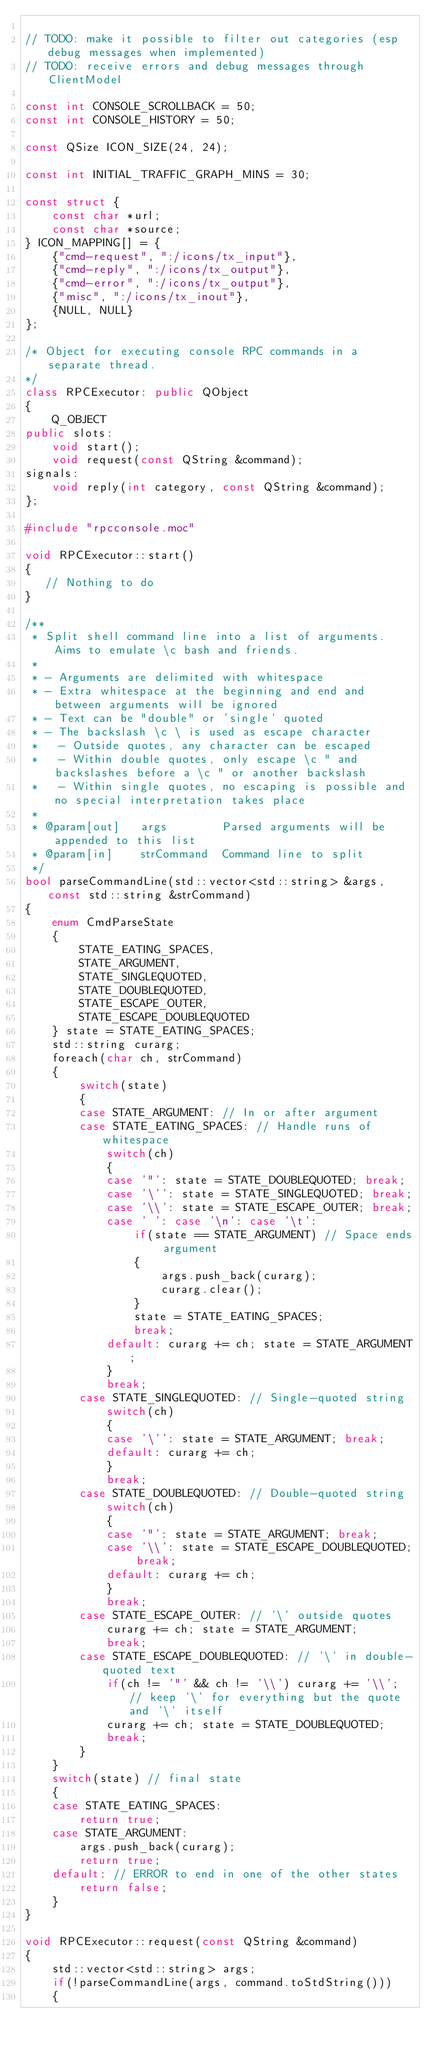Convert code to text. <code><loc_0><loc_0><loc_500><loc_500><_C++_>
// TODO: make it possible to filter out categories (esp debug messages when implemented)
// TODO: receive errors and debug messages through ClientModel

const int CONSOLE_SCROLLBACK = 50;
const int CONSOLE_HISTORY = 50;

const QSize ICON_SIZE(24, 24);

const int INITIAL_TRAFFIC_GRAPH_MINS = 30;

const struct {
    const char *url;
    const char *source;
} ICON_MAPPING[] = {
    {"cmd-request", ":/icons/tx_input"},
    {"cmd-reply", ":/icons/tx_output"},
    {"cmd-error", ":/icons/tx_output"},
    {"misc", ":/icons/tx_inout"},
    {NULL, NULL}
};

/* Object for executing console RPC commands in a separate thread.
*/
class RPCExecutor: public QObject
{
    Q_OBJECT
public slots:
    void start();
    void request(const QString &command);
signals:
    void reply(int category, const QString &command);
};

#include "rpcconsole.moc"

void RPCExecutor::start()
{
   // Nothing to do
}

/**
 * Split shell command line into a list of arguments. Aims to emulate \c bash and friends.
 *
 * - Arguments are delimited with whitespace
 * - Extra whitespace at the beginning and end and between arguments will be ignored
 * - Text can be "double" or 'single' quoted
 * - The backslash \c \ is used as escape character
 *   - Outside quotes, any character can be escaped
 *   - Within double quotes, only escape \c " and backslashes before a \c " or another backslash
 *   - Within single quotes, no escaping is possible and no special interpretation takes place
 *
 * @param[out]   args        Parsed arguments will be appended to this list
 * @param[in]    strCommand  Command line to split
 */
bool parseCommandLine(std::vector<std::string> &args, const std::string &strCommand)
{
    enum CmdParseState
    {
        STATE_EATING_SPACES,
        STATE_ARGUMENT,
        STATE_SINGLEQUOTED,
        STATE_DOUBLEQUOTED,
        STATE_ESCAPE_OUTER,
        STATE_ESCAPE_DOUBLEQUOTED
    } state = STATE_EATING_SPACES;
    std::string curarg;
    foreach(char ch, strCommand)
    {
        switch(state)
        {
        case STATE_ARGUMENT: // In or after argument
        case STATE_EATING_SPACES: // Handle runs of whitespace
            switch(ch)
            {
            case '"': state = STATE_DOUBLEQUOTED; break;
            case '\'': state = STATE_SINGLEQUOTED; break;
            case '\\': state = STATE_ESCAPE_OUTER; break;
            case ' ': case '\n': case '\t':
                if(state == STATE_ARGUMENT) // Space ends argument
                {
                    args.push_back(curarg);
                    curarg.clear();
                }
                state = STATE_EATING_SPACES;
                break;
            default: curarg += ch; state = STATE_ARGUMENT;
            }
            break;
        case STATE_SINGLEQUOTED: // Single-quoted string
            switch(ch)
            {
            case '\'': state = STATE_ARGUMENT; break;
            default: curarg += ch;
            }
            break;
        case STATE_DOUBLEQUOTED: // Double-quoted string
            switch(ch)
            {
            case '"': state = STATE_ARGUMENT; break;
            case '\\': state = STATE_ESCAPE_DOUBLEQUOTED; break;
            default: curarg += ch;
            }
            break;
        case STATE_ESCAPE_OUTER: // '\' outside quotes
            curarg += ch; state = STATE_ARGUMENT;
            break;
        case STATE_ESCAPE_DOUBLEQUOTED: // '\' in double-quoted text
            if(ch != '"' && ch != '\\') curarg += '\\'; // keep '\' for everything but the quote and '\' itself
            curarg += ch; state = STATE_DOUBLEQUOTED;
            break;
        }
    }
    switch(state) // final state
    {
    case STATE_EATING_SPACES:
        return true;
    case STATE_ARGUMENT:
        args.push_back(curarg);
        return true;
    default: // ERROR to end in one of the other states
        return false;
    }
}

void RPCExecutor::request(const QString &command)
{
    std::vector<std::string> args;
    if(!parseCommandLine(args, command.toStdString()))
    {</code> 